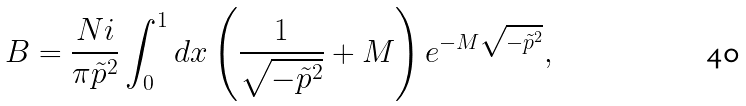<formula> <loc_0><loc_0><loc_500><loc_500>B = \frac { N i } { \pi { \tilde { p } } ^ { 2 } } \int _ { 0 } ^ { 1 } d x \left ( \frac { 1 } { \sqrt { - \tilde { p } ^ { 2 } } } + M \right ) { e } ^ { - M \sqrt { - \tilde { p } ^ { 2 } } } ,</formula> 